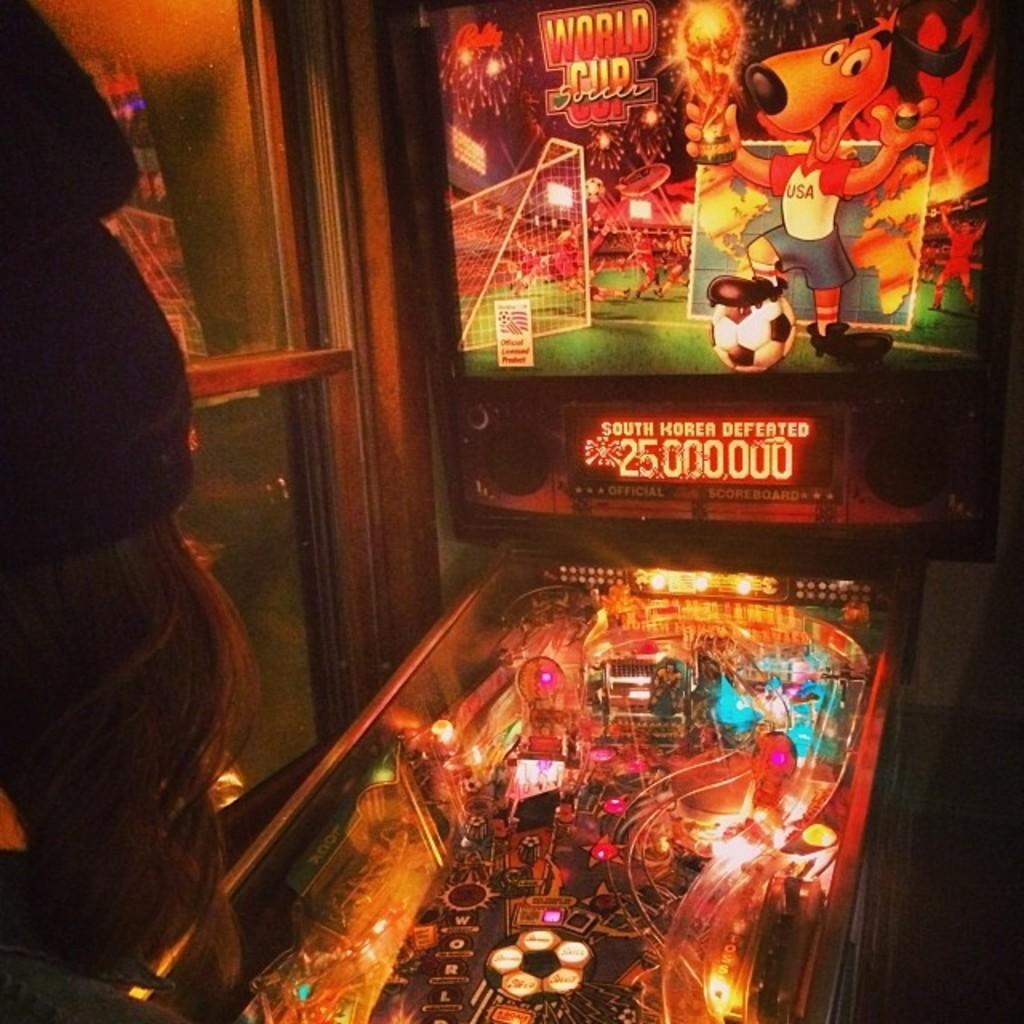How would you summarize this image in a sentence or two? In the picture I can see an LED screen display board on the right side. I can see the glass display box on the floor. There is a woman on the left side though her face is not visible. I can see the glass window on the left side. 